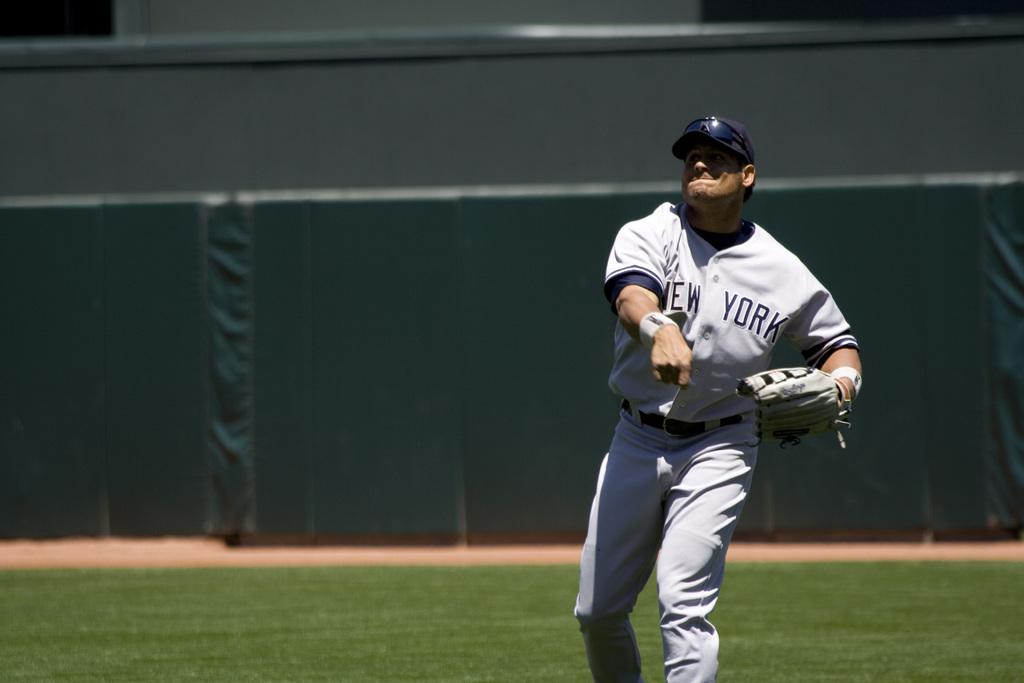<image>
Present a compact description of the photo's key features. A New York baseball player has just thrown a ball with his right hand. 